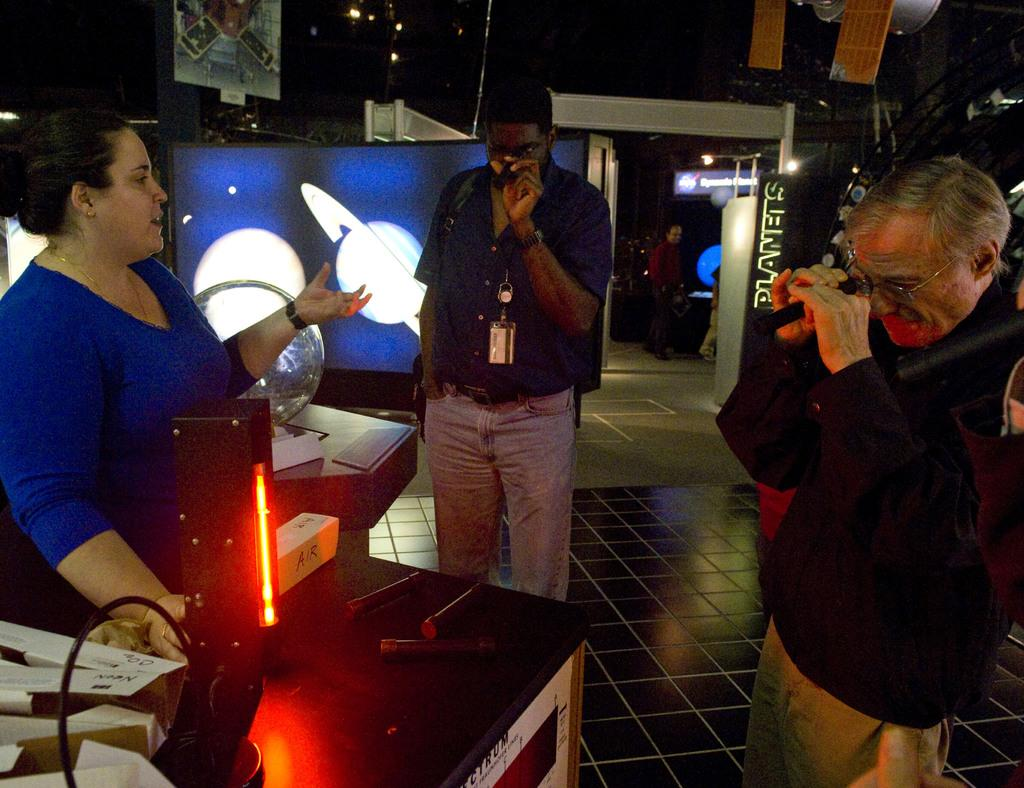What can be seen in the image? There are people standing in the image. Where are the people standing? The people are standing on the floor. What is one specific object visible in the image? There is a globe in the image. Can you describe the background of the image? There are unspecified objects in the background of the image. How many balls are being juggled by the laborer in the image? There is no laborer or balls present in the image. What type of friction is being generated by the objects in the image? The provided facts do not give any information about friction or the nature of the objects in the image. 